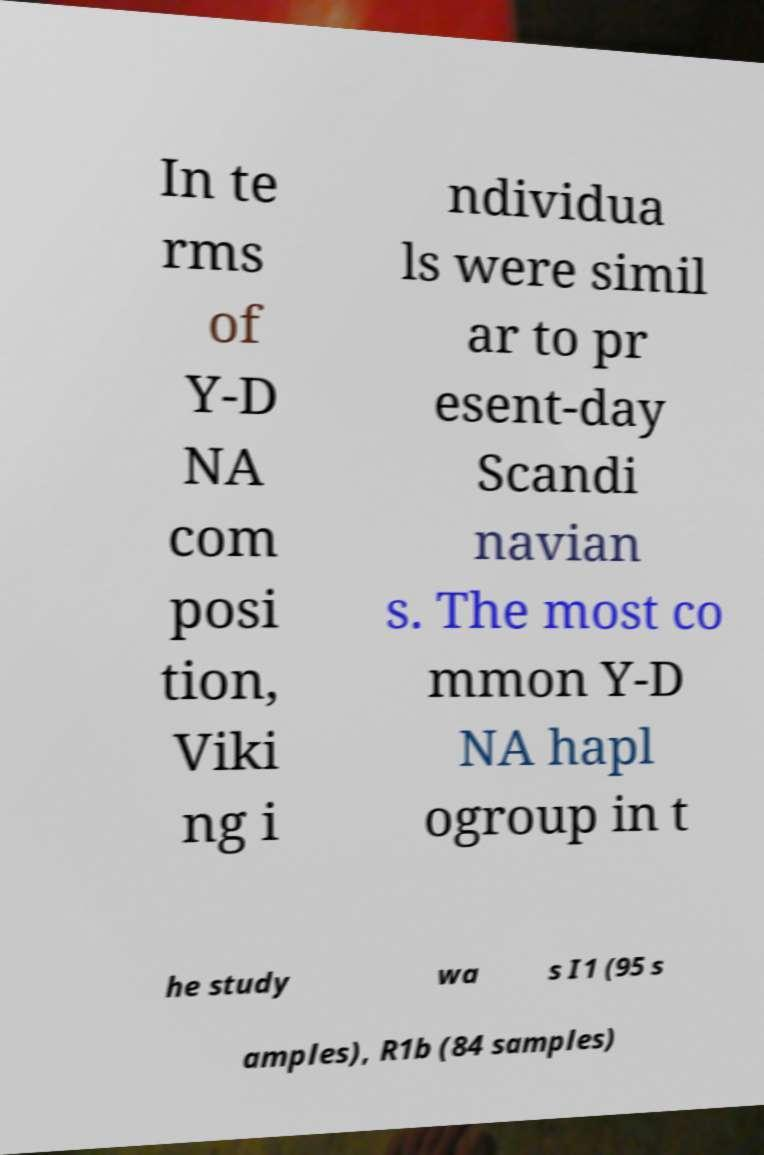Could you extract and type out the text from this image? In te rms of Y-D NA com posi tion, Viki ng i ndividua ls were simil ar to pr esent-day Scandi navian s. The most co mmon Y-D NA hapl ogroup in t he study wa s I1 (95 s amples), R1b (84 samples) 